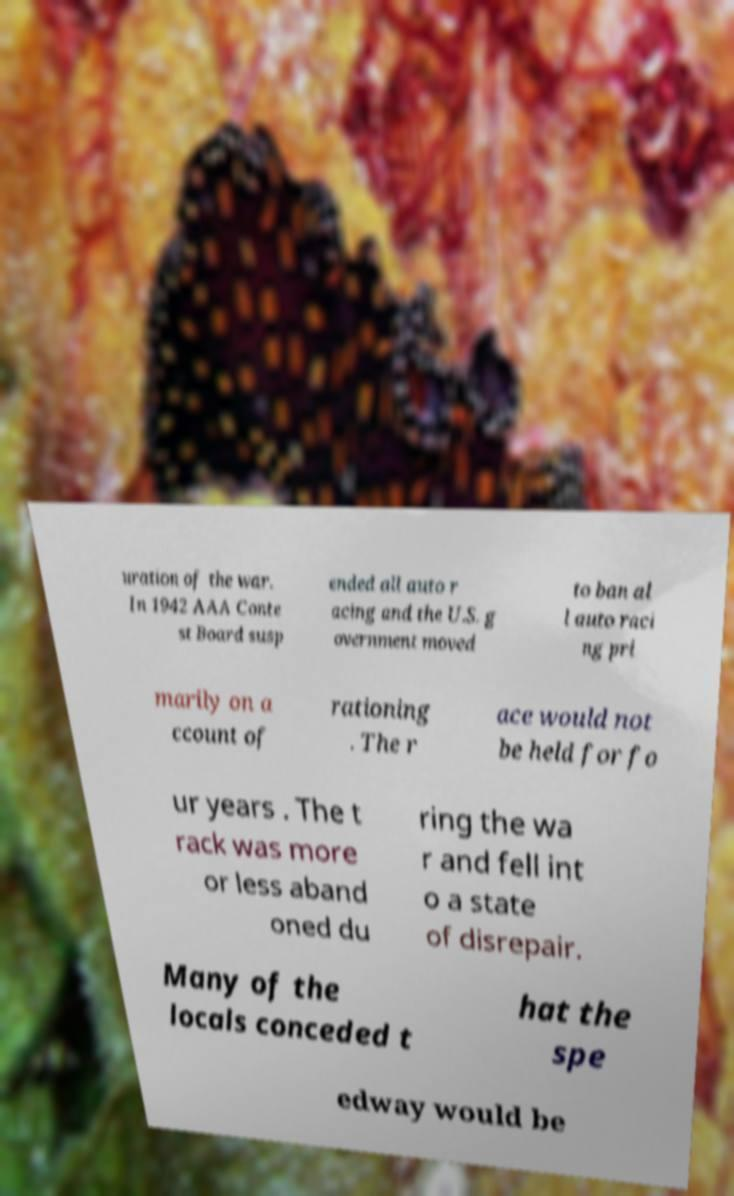Could you assist in decoding the text presented in this image and type it out clearly? uration of the war. In 1942 AAA Conte st Board susp ended all auto r acing and the U.S. g overnment moved to ban al l auto raci ng pri marily on a ccount of rationing . The r ace would not be held for fo ur years . The t rack was more or less aband oned du ring the wa r and fell int o a state of disrepair. Many of the locals conceded t hat the spe edway would be 